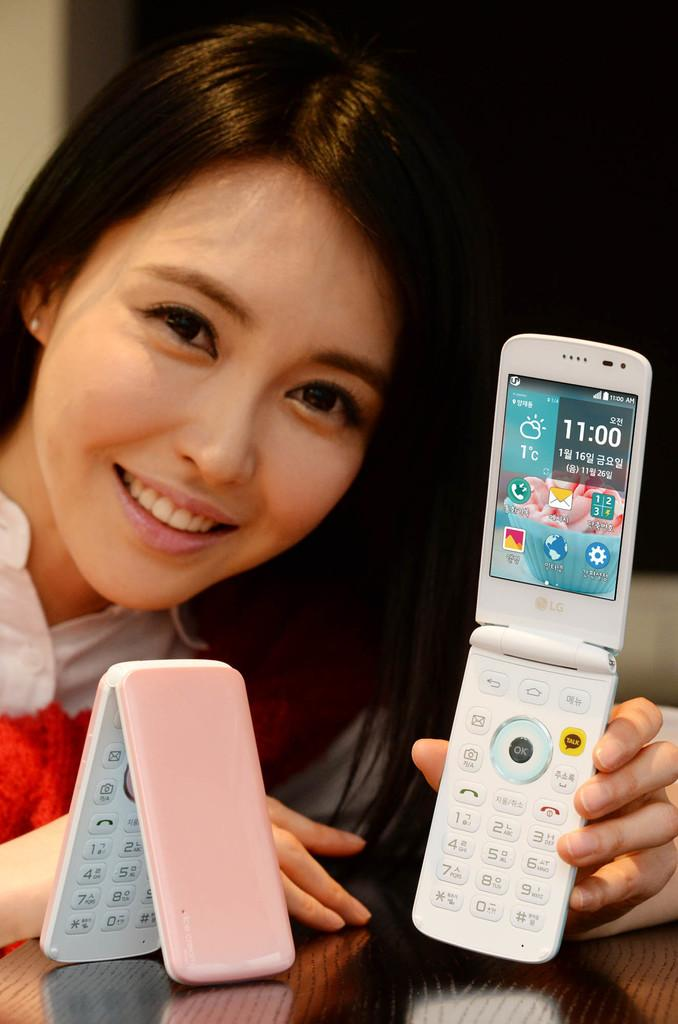<image>
Present a compact description of the photo's key features. An open flip phone with foreign text on it. 